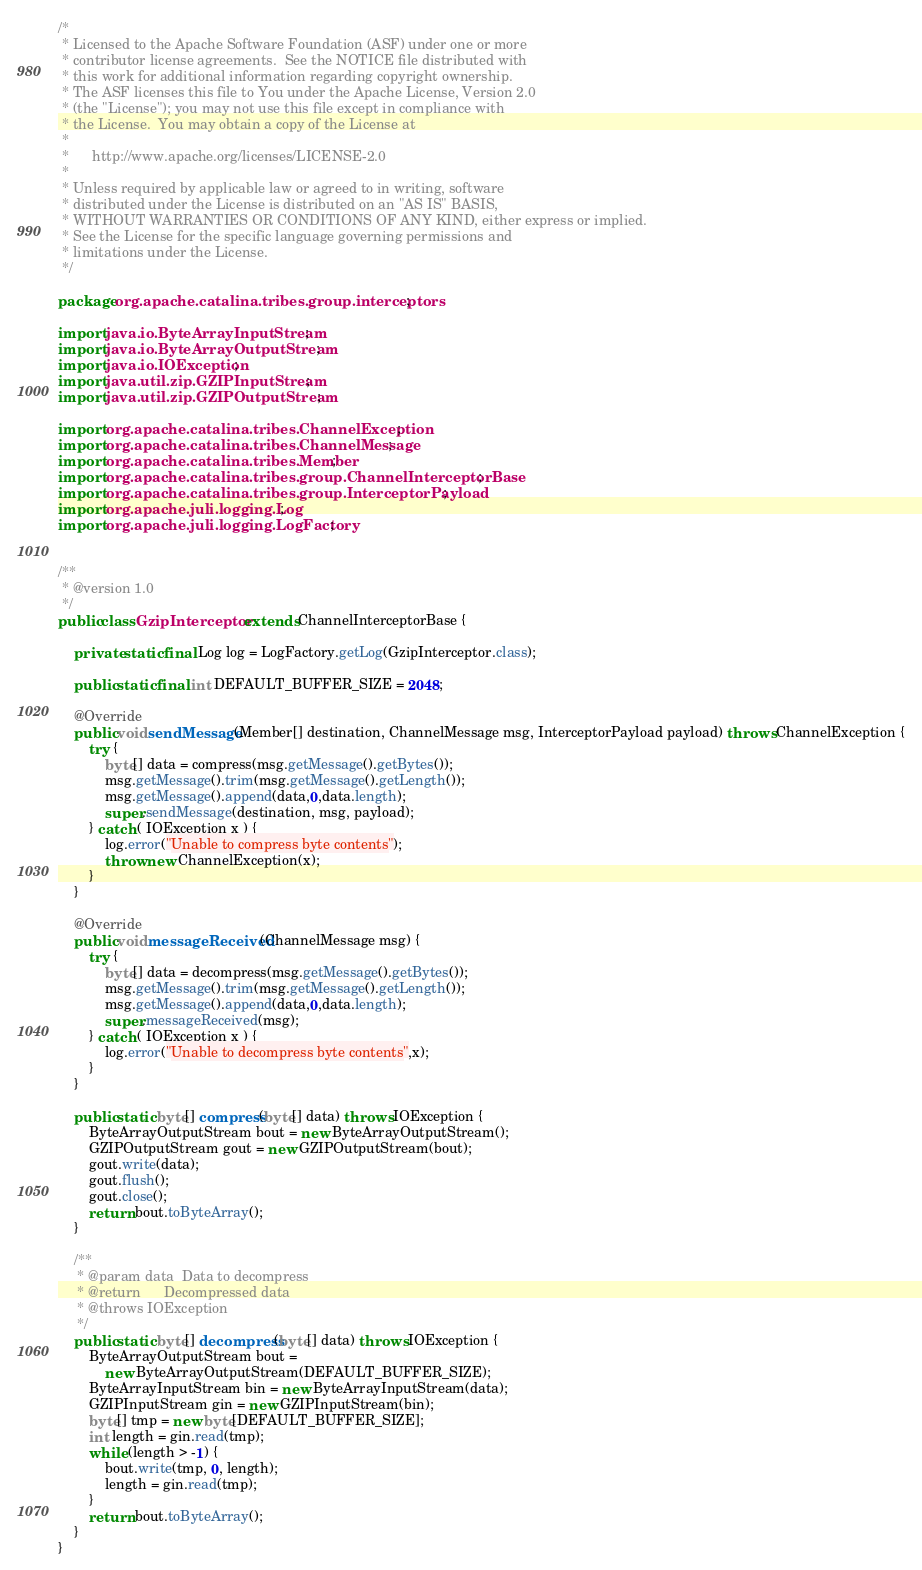<code> <loc_0><loc_0><loc_500><loc_500><_Java_>/*
 * Licensed to the Apache Software Foundation (ASF) under one or more
 * contributor license agreements.  See the NOTICE file distributed with
 * this work for additional information regarding copyright ownership.
 * The ASF licenses this file to You under the Apache License, Version 2.0
 * (the "License"); you may not use this file except in compliance with
 * the License.  You may obtain a copy of the License at
 *
 *      http://www.apache.org/licenses/LICENSE-2.0
 *
 * Unless required by applicable law or agreed to in writing, software
 * distributed under the License is distributed on an "AS IS" BASIS,
 * WITHOUT WARRANTIES OR CONDITIONS OF ANY KIND, either express or implied.
 * See the License for the specific language governing permissions and
 * limitations under the License.
 */

package org.apache.catalina.tribes.group.interceptors;

import java.io.ByteArrayInputStream;
import java.io.ByteArrayOutputStream;
import java.io.IOException;
import java.util.zip.GZIPInputStream;
import java.util.zip.GZIPOutputStream;

import org.apache.catalina.tribes.ChannelException;
import org.apache.catalina.tribes.ChannelMessage;
import org.apache.catalina.tribes.Member;
import org.apache.catalina.tribes.group.ChannelInterceptorBase;
import org.apache.catalina.tribes.group.InterceptorPayload;
import org.apache.juli.logging.Log;
import org.apache.juli.logging.LogFactory;


/**
 * @version 1.0
 */
public class GzipInterceptor extends ChannelInterceptorBase {

    private static final Log log = LogFactory.getLog(GzipInterceptor.class);

    public static final int DEFAULT_BUFFER_SIZE = 2048;

    @Override
    public void sendMessage(Member[] destination, ChannelMessage msg, InterceptorPayload payload) throws ChannelException {
        try {
            byte[] data = compress(msg.getMessage().getBytes());
            msg.getMessage().trim(msg.getMessage().getLength());
            msg.getMessage().append(data,0,data.length);
            super.sendMessage(destination, msg, payload);
        } catch ( IOException x ) {
            log.error("Unable to compress byte contents");
            throw new ChannelException(x);
        }
    }

    @Override
    public void messageReceived(ChannelMessage msg) {
        try {
            byte[] data = decompress(msg.getMessage().getBytes());
            msg.getMessage().trim(msg.getMessage().getLength());
            msg.getMessage().append(data,0,data.length);
            super.messageReceived(msg);
        } catch ( IOException x ) {
            log.error("Unable to decompress byte contents",x);
        }
    }

    public static byte[] compress(byte[] data) throws IOException {
        ByteArrayOutputStream bout = new ByteArrayOutputStream();
        GZIPOutputStream gout = new GZIPOutputStream(bout);
        gout.write(data);
        gout.flush();
        gout.close();
        return bout.toByteArray();
    }

    /**
     * @param data  Data to decompress
     * @return      Decompressed data
     * @throws IOException
     */
    public static byte[] decompress(byte[] data) throws IOException {
        ByteArrayOutputStream bout =
            new ByteArrayOutputStream(DEFAULT_BUFFER_SIZE);
        ByteArrayInputStream bin = new ByteArrayInputStream(data);
        GZIPInputStream gin = new GZIPInputStream(bin);
        byte[] tmp = new byte[DEFAULT_BUFFER_SIZE];
        int length = gin.read(tmp);
        while (length > -1) {
            bout.write(tmp, 0, length);
            length = gin.read(tmp);
        }
        return bout.toByteArray();
    }
}
</code> 